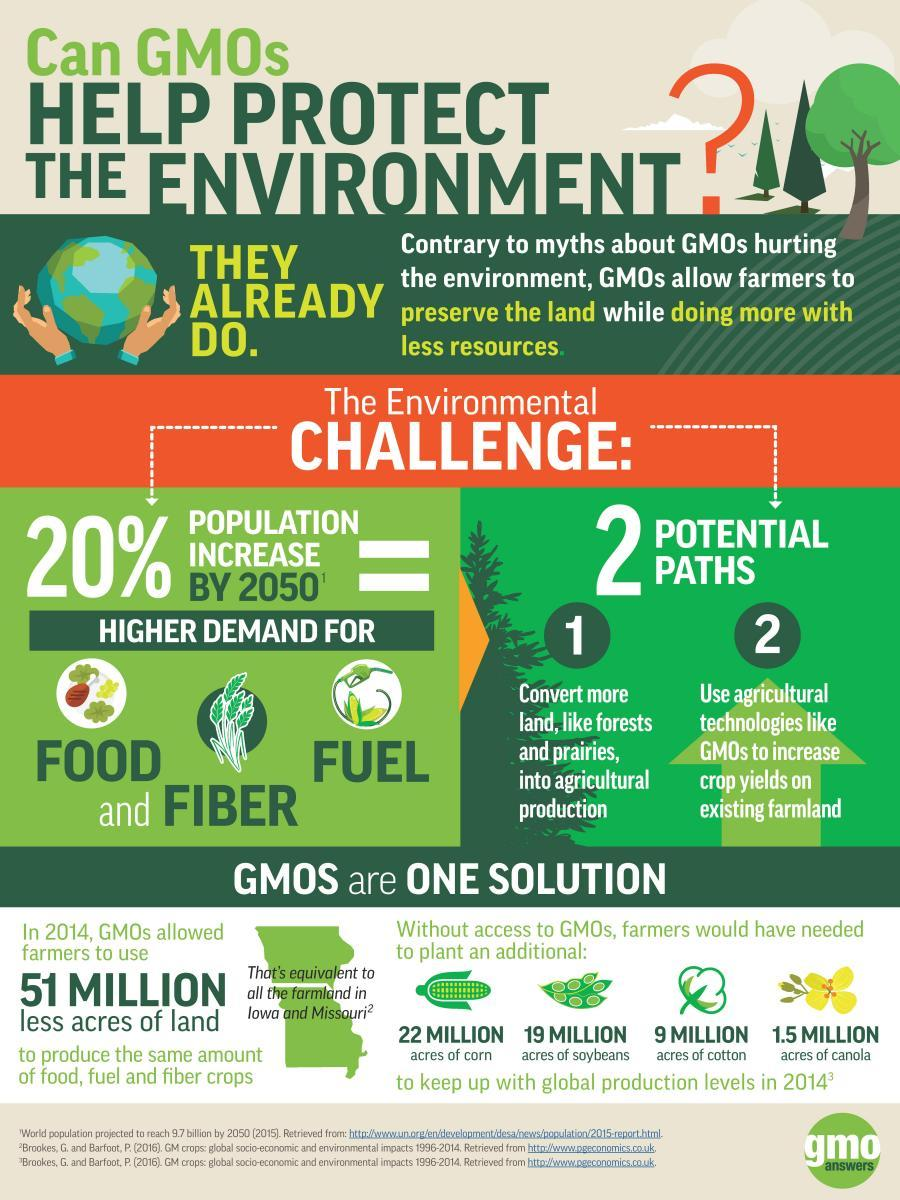Outline some significant characteristics in this image. Genetically modified organisms (GMOs) help farmers preserve the land and do more with fewer resources. Genetically modified organisms (GMOs) have played a significant role in reducing the need for land expansion in the agricultural industry. Without the use of GMOs, it is estimated that an additional 9 million acres of land would have been required for the cultivation of cotton. In Iowa and Mussoorie, the total farmlands have an area of 51 million acres. If it were not for the use of GMOs, an additional 22 million acres of land would be needed to produce corn, one of the most widely cultivated food crops in the world. If not for the use of GMOs, an additional 22 million acres of corn would have been required to meet the same demand. 